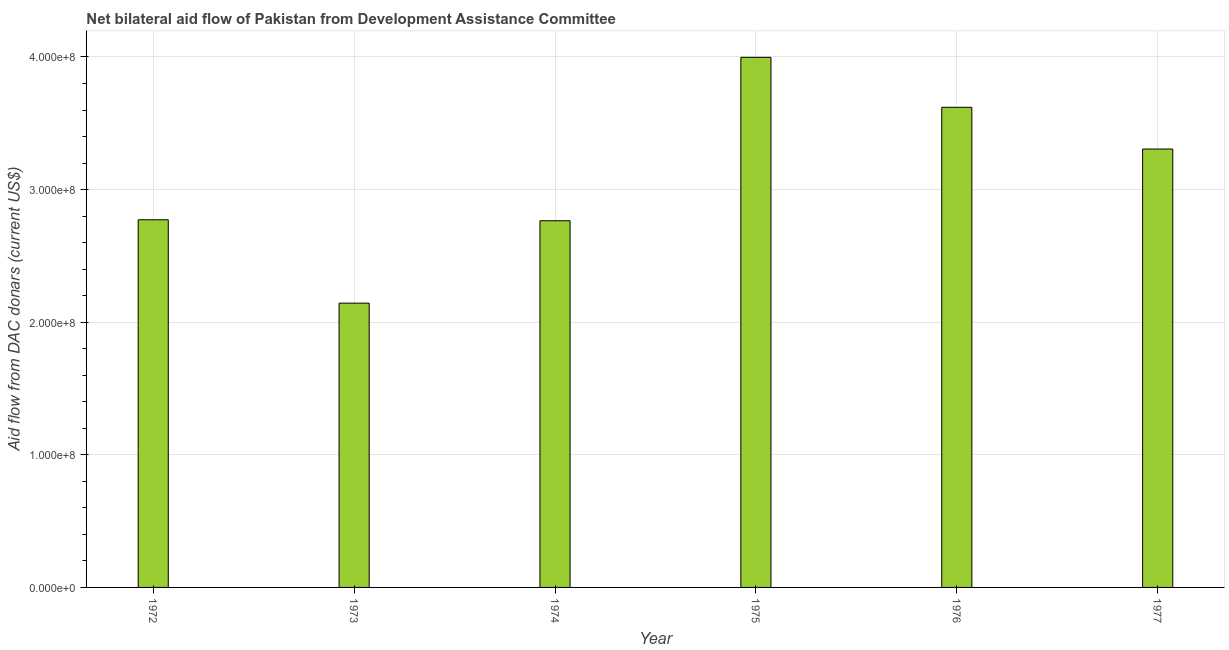Does the graph contain any zero values?
Your answer should be compact. No. Does the graph contain grids?
Your answer should be very brief. Yes. What is the title of the graph?
Your answer should be very brief. Net bilateral aid flow of Pakistan from Development Assistance Committee. What is the label or title of the Y-axis?
Your answer should be very brief. Aid flow from DAC donars (current US$). What is the net bilateral aid flows from dac donors in 1972?
Make the answer very short. 2.77e+08. Across all years, what is the maximum net bilateral aid flows from dac donors?
Your answer should be compact. 4.00e+08. Across all years, what is the minimum net bilateral aid flows from dac donors?
Keep it short and to the point. 2.14e+08. In which year was the net bilateral aid flows from dac donors maximum?
Offer a terse response. 1975. What is the sum of the net bilateral aid flows from dac donors?
Your answer should be very brief. 1.86e+09. What is the difference between the net bilateral aid flows from dac donors in 1974 and 1977?
Provide a succinct answer. -5.41e+07. What is the average net bilateral aid flows from dac donors per year?
Ensure brevity in your answer.  3.10e+08. What is the median net bilateral aid flows from dac donors?
Provide a short and direct response. 3.04e+08. In how many years, is the net bilateral aid flows from dac donors greater than 80000000 US$?
Provide a succinct answer. 6. Do a majority of the years between 1974 and 1973 (inclusive) have net bilateral aid flows from dac donors greater than 160000000 US$?
Your answer should be very brief. No. What is the ratio of the net bilateral aid flows from dac donors in 1972 to that in 1975?
Offer a very short reply. 0.69. Is the net bilateral aid flows from dac donors in 1972 less than that in 1974?
Your response must be concise. No. Is the difference between the net bilateral aid flows from dac donors in 1973 and 1977 greater than the difference between any two years?
Your answer should be very brief. No. What is the difference between the highest and the second highest net bilateral aid flows from dac donors?
Offer a very short reply. 3.77e+07. Is the sum of the net bilateral aid flows from dac donors in 1973 and 1974 greater than the maximum net bilateral aid flows from dac donors across all years?
Provide a succinct answer. Yes. What is the difference between the highest and the lowest net bilateral aid flows from dac donors?
Your answer should be very brief. 1.85e+08. How many bars are there?
Give a very brief answer. 6. Are all the bars in the graph horizontal?
Offer a very short reply. No. What is the difference between two consecutive major ticks on the Y-axis?
Your answer should be very brief. 1.00e+08. What is the Aid flow from DAC donars (current US$) in 1972?
Offer a very short reply. 2.77e+08. What is the Aid flow from DAC donars (current US$) in 1973?
Provide a short and direct response. 2.14e+08. What is the Aid flow from DAC donars (current US$) in 1974?
Offer a terse response. 2.77e+08. What is the Aid flow from DAC donars (current US$) of 1975?
Offer a very short reply. 4.00e+08. What is the Aid flow from DAC donars (current US$) of 1976?
Provide a succinct answer. 3.62e+08. What is the Aid flow from DAC donars (current US$) of 1977?
Offer a terse response. 3.31e+08. What is the difference between the Aid flow from DAC donars (current US$) in 1972 and 1973?
Ensure brevity in your answer.  6.29e+07. What is the difference between the Aid flow from DAC donars (current US$) in 1972 and 1974?
Ensure brevity in your answer.  7.30e+05. What is the difference between the Aid flow from DAC donars (current US$) in 1972 and 1975?
Provide a succinct answer. -1.22e+08. What is the difference between the Aid flow from DAC donars (current US$) in 1972 and 1976?
Give a very brief answer. -8.48e+07. What is the difference between the Aid flow from DAC donars (current US$) in 1972 and 1977?
Keep it short and to the point. -5.34e+07. What is the difference between the Aid flow from DAC donars (current US$) in 1973 and 1974?
Your response must be concise. -6.21e+07. What is the difference between the Aid flow from DAC donars (current US$) in 1973 and 1975?
Keep it short and to the point. -1.85e+08. What is the difference between the Aid flow from DAC donars (current US$) in 1973 and 1976?
Give a very brief answer. -1.48e+08. What is the difference between the Aid flow from DAC donars (current US$) in 1973 and 1977?
Provide a succinct answer. -1.16e+08. What is the difference between the Aid flow from DAC donars (current US$) in 1974 and 1975?
Offer a very short reply. -1.23e+08. What is the difference between the Aid flow from DAC donars (current US$) in 1974 and 1976?
Your answer should be very brief. -8.55e+07. What is the difference between the Aid flow from DAC donars (current US$) in 1974 and 1977?
Make the answer very short. -5.41e+07. What is the difference between the Aid flow from DAC donars (current US$) in 1975 and 1976?
Give a very brief answer. 3.77e+07. What is the difference between the Aid flow from DAC donars (current US$) in 1975 and 1977?
Make the answer very short. 6.91e+07. What is the difference between the Aid flow from DAC donars (current US$) in 1976 and 1977?
Make the answer very short. 3.14e+07. What is the ratio of the Aid flow from DAC donars (current US$) in 1972 to that in 1973?
Ensure brevity in your answer.  1.29. What is the ratio of the Aid flow from DAC donars (current US$) in 1972 to that in 1974?
Your answer should be very brief. 1. What is the ratio of the Aid flow from DAC donars (current US$) in 1972 to that in 1975?
Provide a short and direct response. 0.69. What is the ratio of the Aid flow from DAC donars (current US$) in 1972 to that in 1976?
Provide a succinct answer. 0.77. What is the ratio of the Aid flow from DAC donars (current US$) in 1972 to that in 1977?
Your answer should be very brief. 0.84. What is the ratio of the Aid flow from DAC donars (current US$) in 1973 to that in 1974?
Your answer should be compact. 0.78. What is the ratio of the Aid flow from DAC donars (current US$) in 1973 to that in 1975?
Your answer should be compact. 0.54. What is the ratio of the Aid flow from DAC donars (current US$) in 1973 to that in 1976?
Your answer should be compact. 0.59. What is the ratio of the Aid flow from DAC donars (current US$) in 1973 to that in 1977?
Keep it short and to the point. 0.65. What is the ratio of the Aid flow from DAC donars (current US$) in 1974 to that in 1975?
Make the answer very short. 0.69. What is the ratio of the Aid flow from DAC donars (current US$) in 1974 to that in 1976?
Give a very brief answer. 0.76. What is the ratio of the Aid flow from DAC donars (current US$) in 1974 to that in 1977?
Your answer should be very brief. 0.84. What is the ratio of the Aid flow from DAC donars (current US$) in 1975 to that in 1976?
Your answer should be compact. 1.1. What is the ratio of the Aid flow from DAC donars (current US$) in 1975 to that in 1977?
Your answer should be very brief. 1.21. What is the ratio of the Aid flow from DAC donars (current US$) in 1976 to that in 1977?
Your answer should be very brief. 1.09. 